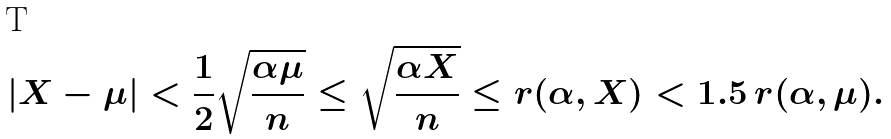<formula> <loc_0><loc_0><loc_500><loc_500>| X - \mu | < \frac { 1 } { 2 } \sqrt { \frac { \alpha \mu } { n } } \leq \sqrt { \frac { \alpha X } { n } } \leq r ( \alpha , X ) < 1 . 5 \, r ( \alpha , \mu ) .</formula> 